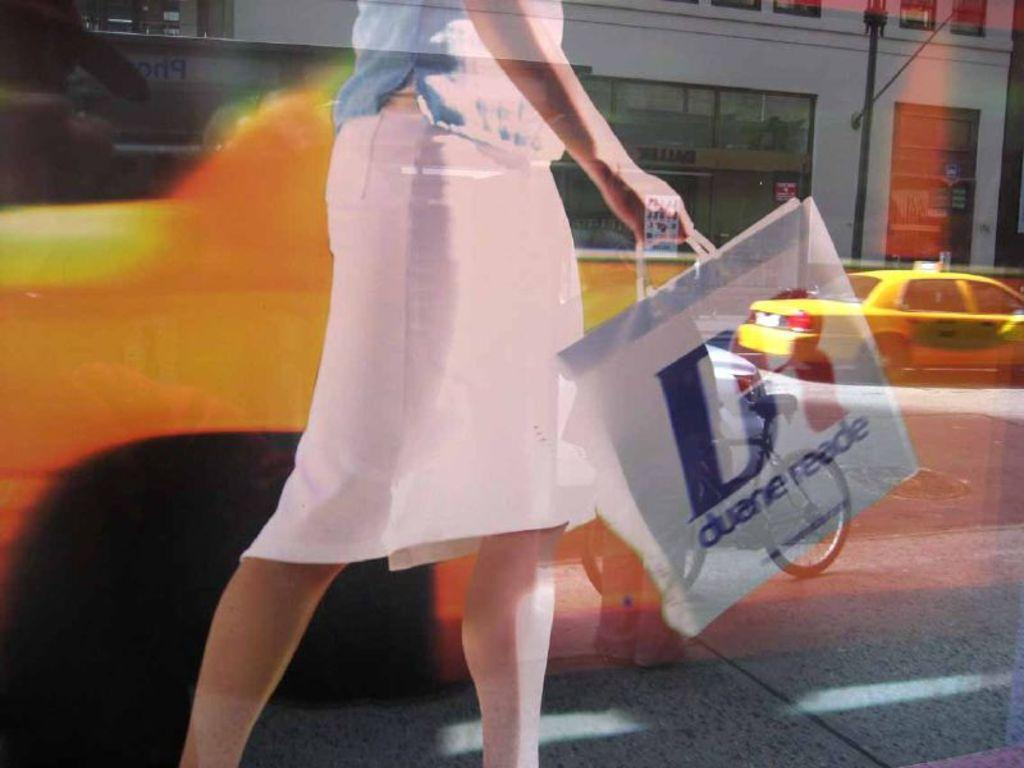<image>
Create a compact narrative representing the image presented. A woman carrying a bag with Duene Reade written on it. 